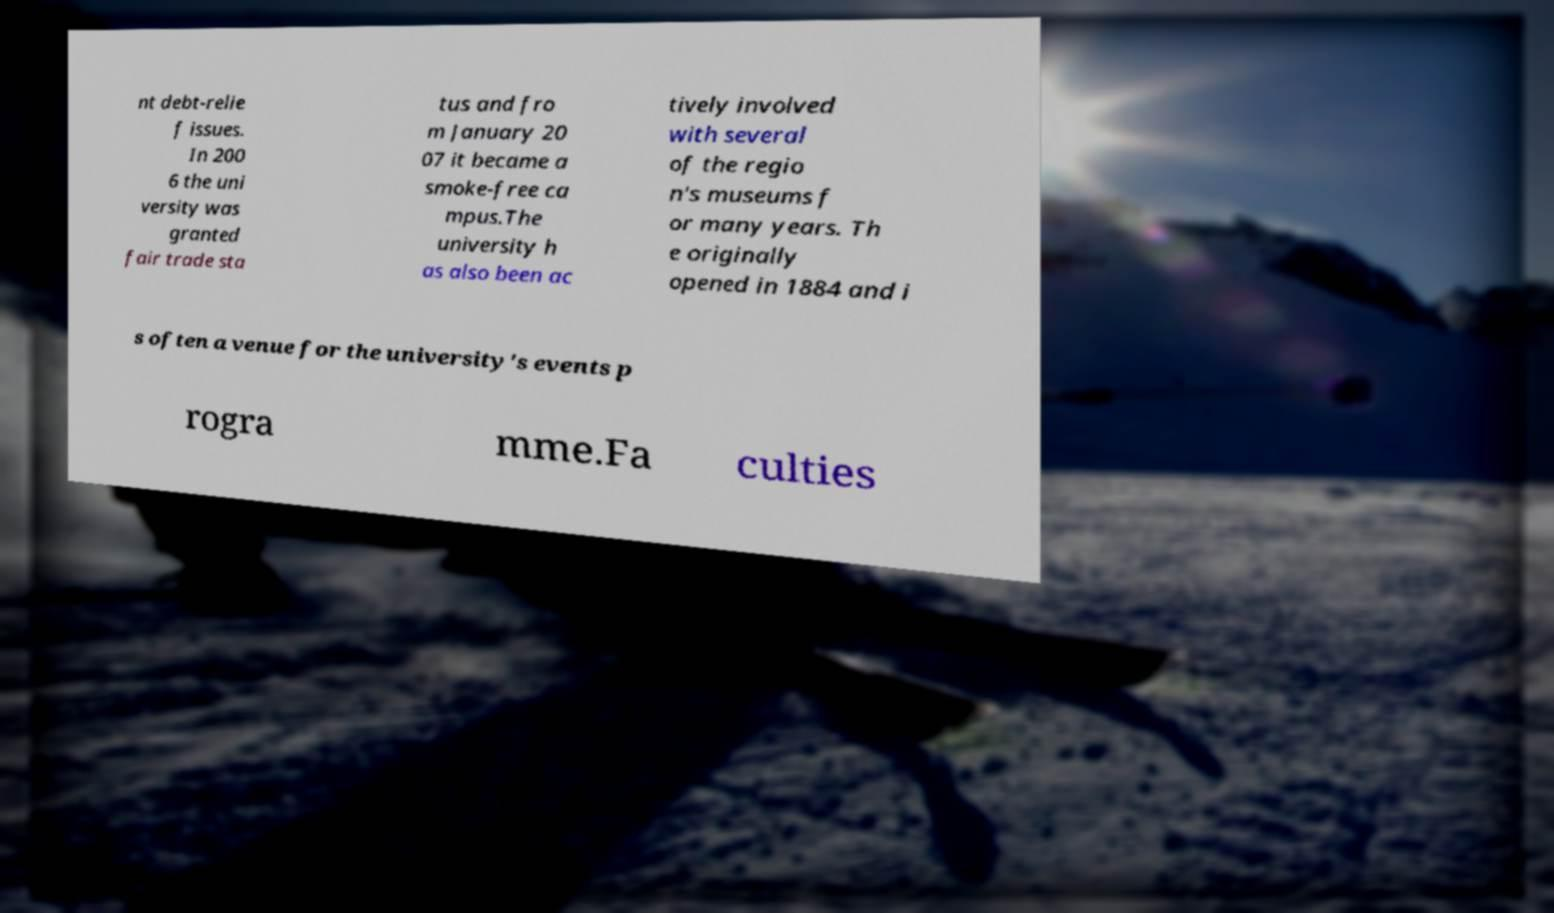For documentation purposes, I need the text within this image transcribed. Could you provide that? nt debt-relie f issues. In 200 6 the uni versity was granted fair trade sta tus and fro m January 20 07 it became a smoke-free ca mpus.The university h as also been ac tively involved with several of the regio n's museums f or many years. Th e originally opened in 1884 and i s often a venue for the university's events p rogra mme.Fa culties 